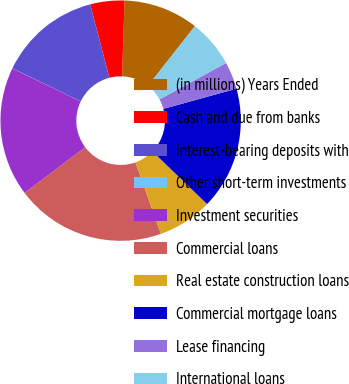Convert chart to OTSL. <chart><loc_0><loc_0><loc_500><loc_500><pie_chart><fcel>(in millions) Years Ended<fcel>Cash and due from banks<fcel>Interest-bearing deposits with<fcel>Other short-term investments<fcel>Investment securities<fcel>Commercial loans<fcel>Real estate construction loans<fcel>Commercial mortgage loans<fcel>Lease financing<fcel>International loans<nl><fcel>10.09%<fcel>4.6%<fcel>13.76%<fcel>0.02%<fcel>17.42%<fcel>20.17%<fcel>7.34%<fcel>16.5%<fcel>3.68%<fcel>6.43%<nl></chart> 